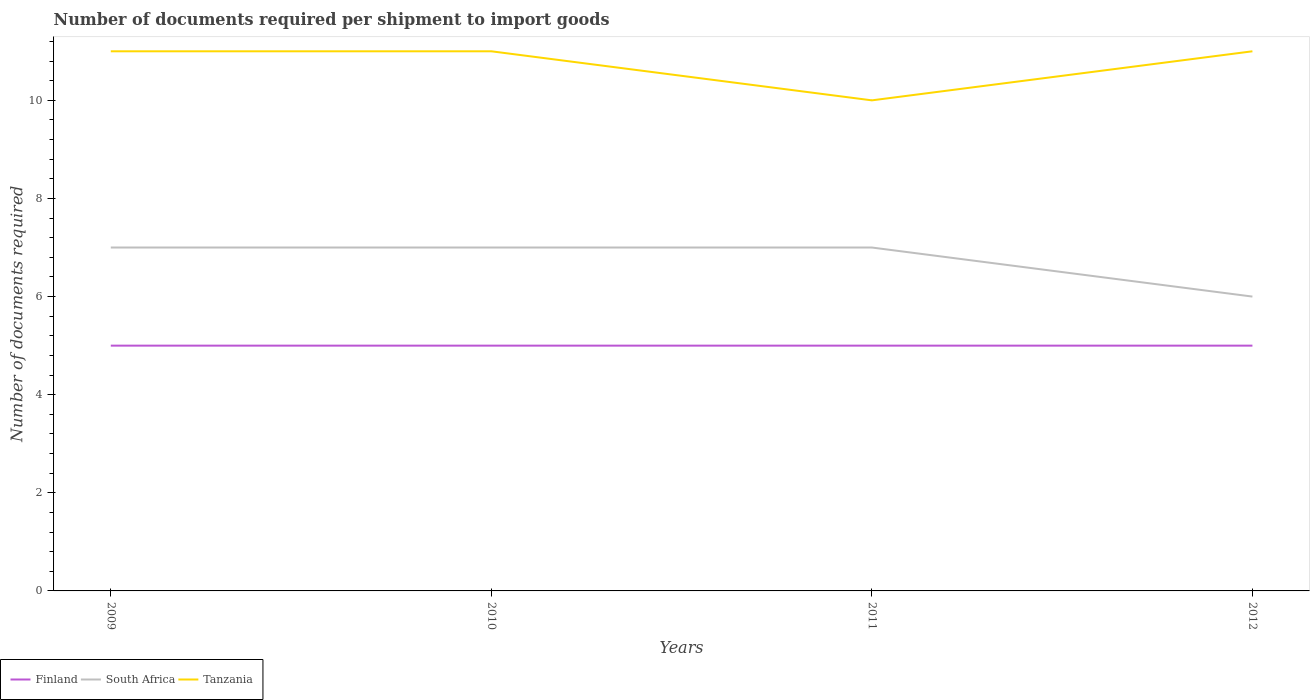Does the line corresponding to Finland intersect with the line corresponding to South Africa?
Give a very brief answer. No. Is the number of lines equal to the number of legend labels?
Make the answer very short. Yes. Across all years, what is the maximum number of documents required per shipment to import goods in Finland?
Provide a short and direct response. 5. Is the number of documents required per shipment to import goods in Tanzania strictly greater than the number of documents required per shipment to import goods in South Africa over the years?
Your answer should be very brief. No. How many years are there in the graph?
Ensure brevity in your answer.  4. Are the values on the major ticks of Y-axis written in scientific E-notation?
Ensure brevity in your answer.  No. Does the graph contain any zero values?
Give a very brief answer. No. How many legend labels are there?
Provide a succinct answer. 3. How are the legend labels stacked?
Your answer should be very brief. Horizontal. What is the title of the graph?
Provide a succinct answer. Number of documents required per shipment to import goods. Does "Latin America(developing only)" appear as one of the legend labels in the graph?
Your answer should be compact. No. What is the label or title of the Y-axis?
Keep it short and to the point. Number of documents required. What is the Number of documents required in South Africa in 2009?
Your answer should be compact. 7. What is the Number of documents required of South Africa in 2010?
Provide a succinct answer. 7. Across all years, what is the maximum Number of documents required of Tanzania?
Your answer should be compact. 11. What is the total Number of documents required in Finland in the graph?
Give a very brief answer. 20. What is the difference between the Number of documents required in Finland in 2009 and that in 2010?
Provide a short and direct response. 0. What is the difference between the Number of documents required in South Africa in 2009 and that in 2011?
Offer a very short reply. 0. What is the difference between the Number of documents required in Finland in 2009 and that in 2012?
Make the answer very short. 0. What is the difference between the Number of documents required in Finland in 2010 and that in 2011?
Make the answer very short. 0. What is the difference between the Number of documents required in South Africa in 2010 and that in 2011?
Provide a succinct answer. 0. What is the difference between the Number of documents required of Finland in 2010 and that in 2012?
Make the answer very short. 0. What is the difference between the Number of documents required in South Africa in 2010 and that in 2012?
Provide a succinct answer. 1. What is the difference between the Number of documents required of Finland in 2011 and that in 2012?
Offer a terse response. 0. What is the difference between the Number of documents required in South Africa in 2011 and that in 2012?
Your answer should be very brief. 1. What is the difference between the Number of documents required in Finland in 2009 and the Number of documents required in Tanzania in 2010?
Ensure brevity in your answer.  -6. What is the difference between the Number of documents required of South Africa in 2009 and the Number of documents required of Tanzania in 2010?
Offer a very short reply. -4. What is the difference between the Number of documents required in Finland in 2009 and the Number of documents required in Tanzania in 2011?
Offer a very short reply. -5. What is the difference between the Number of documents required in South Africa in 2009 and the Number of documents required in Tanzania in 2012?
Offer a very short reply. -4. What is the difference between the Number of documents required in Finland in 2010 and the Number of documents required in Tanzania in 2011?
Provide a short and direct response. -5. What is the difference between the Number of documents required of South Africa in 2010 and the Number of documents required of Tanzania in 2011?
Ensure brevity in your answer.  -3. What is the difference between the Number of documents required in Finland in 2010 and the Number of documents required in South Africa in 2012?
Give a very brief answer. -1. What is the difference between the Number of documents required of Finland in 2010 and the Number of documents required of Tanzania in 2012?
Give a very brief answer. -6. What is the difference between the Number of documents required of South Africa in 2010 and the Number of documents required of Tanzania in 2012?
Make the answer very short. -4. What is the difference between the Number of documents required in Finland in 2011 and the Number of documents required in South Africa in 2012?
Provide a succinct answer. -1. What is the average Number of documents required in Finland per year?
Give a very brief answer. 5. What is the average Number of documents required of South Africa per year?
Offer a very short reply. 6.75. What is the average Number of documents required in Tanzania per year?
Make the answer very short. 10.75. In the year 2010, what is the difference between the Number of documents required in Finland and Number of documents required in South Africa?
Offer a very short reply. -2. In the year 2010, what is the difference between the Number of documents required in South Africa and Number of documents required in Tanzania?
Make the answer very short. -4. In the year 2011, what is the difference between the Number of documents required of Finland and Number of documents required of South Africa?
Give a very brief answer. -2. In the year 2011, what is the difference between the Number of documents required of Finland and Number of documents required of Tanzania?
Keep it short and to the point. -5. In the year 2011, what is the difference between the Number of documents required of South Africa and Number of documents required of Tanzania?
Ensure brevity in your answer.  -3. In the year 2012, what is the difference between the Number of documents required in South Africa and Number of documents required in Tanzania?
Keep it short and to the point. -5. What is the ratio of the Number of documents required of South Africa in 2009 to that in 2010?
Your response must be concise. 1. What is the ratio of the Number of documents required in South Africa in 2009 to that in 2011?
Your answer should be compact. 1. What is the ratio of the Number of documents required in Finland in 2009 to that in 2012?
Give a very brief answer. 1. What is the ratio of the Number of documents required in South Africa in 2010 to that in 2011?
Ensure brevity in your answer.  1. What is the ratio of the Number of documents required of Tanzania in 2010 to that in 2011?
Give a very brief answer. 1.1. What is the ratio of the Number of documents required in Finland in 2010 to that in 2012?
Make the answer very short. 1. What is the ratio of the Number of documents required in South Africa in 2010 to that in 2012?
Give a very brief answer. 1.17. What is the ratio of the Number of documents required in Tanzania in 2010 to that in 2012?
Give a very brief answer. 1. What is the ratio of the Number of documents required of Finland in 2011 to that in 2012?
Provide a succinct answer. 1. What is the ratio of the Number of documents required in South Africa in 2011 to that in 2012?
Provide a short and direct response. 1.17. What is the ratio of the Number of documents required of Tanzania in 2011 to that in 2012?
Offer a terse response. 0.91. What is the difference between the highest and the lowest Number of documents required in Finland?
Offer a terse response. 0. What is the difference between the highest and the lowest Number of documents required of South Africa?
Offer a terse response. 1. What is the difference between the highest and the lowest Number of documents required of Tanzania?
Offer a very short reply. 1. 